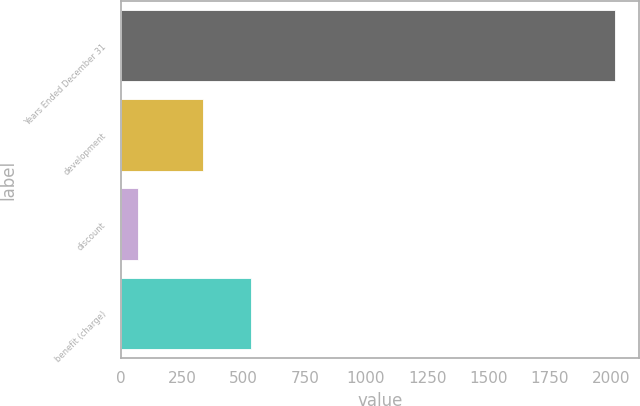Convert chart. <chart><loc_0><loc_0><loc_500><loc_500><bar_chart><fcel>Years Ended December 31<fcel>development<fcel>discount<fcel>benefit (charge)<nl><fcel>2014<fcel>336<fcel>71<fcel>530.3<nl></chart> 